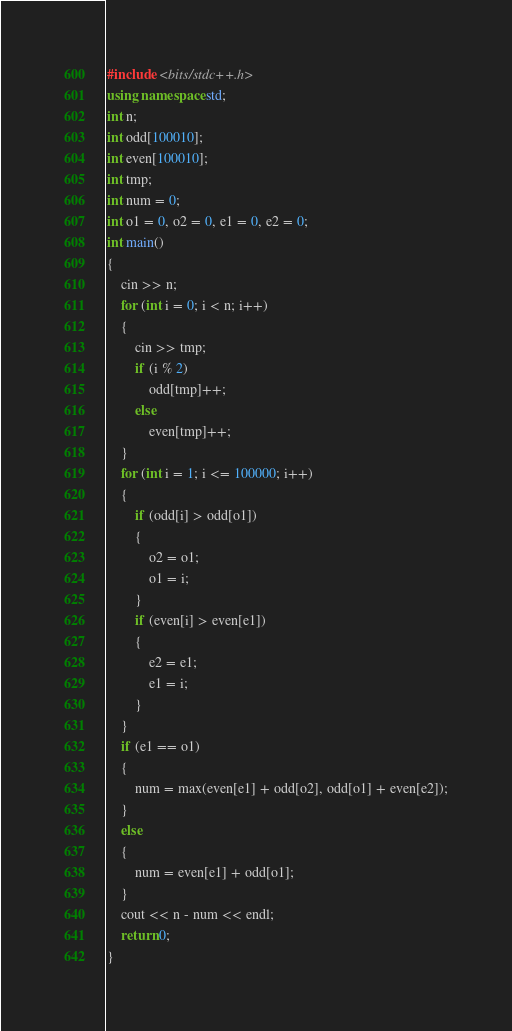<code> <loc_0><loc_0><loc_500><loc_500><_C++_>#include <bits/stdc++.h>
using namespace std;
int n;
int odd[100010];
int even[100010];
int tmp;
int num = 0;
int o1 = 0, o2 = 0, e1 = 0, e2 = 0;
int main()
{
    cin >> n;
    for (int i = 0; i < n; i++)
    {
        cin >> tmp;
        if (i % 2)
            odd[tmp]++;
        else
            even[tmp]++;
    }
    for (int i = 1; i <= 100000; i++)
    {
        if (odd[i] > odd[o1])
        {
            o2 = o1;
            o1 = i;
        }
        if (even[i] > even[e1])
        {
            e2 = e1;
            e1 = i;
        }
    }
    if (e1 == o1)
    {
        num = max(even[e1] + odd[o2], odd[o1] + even[e2]);
    }
    else
    {
        num = even[e1] + odd[o1];
    }
    cout << n - num << endl;
    return 0;
}</code> 